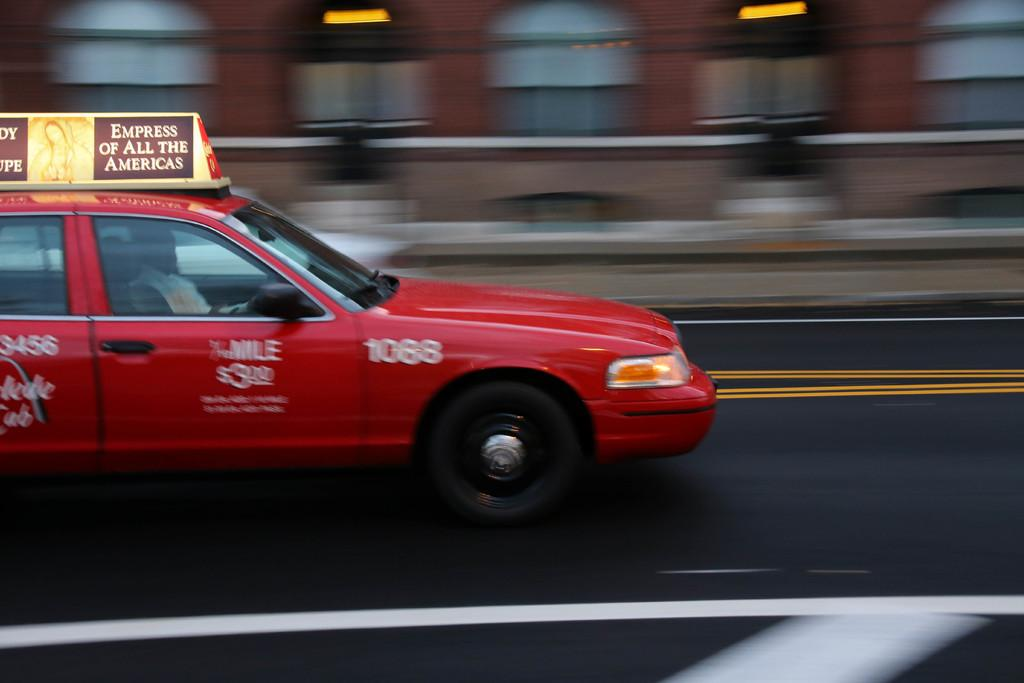<image>
Summarize the visual content of the image. A taxi with an ad for the Empress of All the Americas on the top of it. 